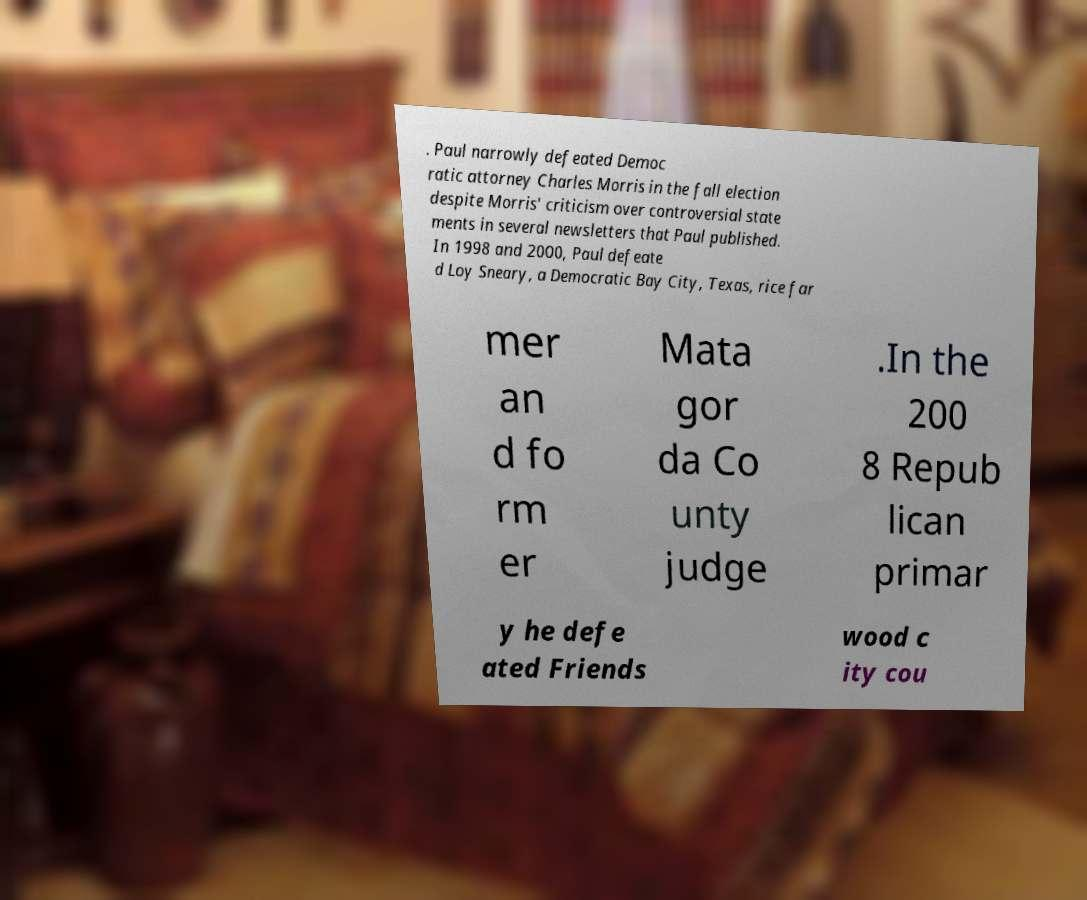Please read and relay the text visible in this image. What does it say? . Paul narrowly defeated Democ ratic attorney Charles Morris in the fall election despite Morris' criticism over controversial state ments in several newsletters that Paul published. In 1998 and 2000, Paul defeate d Loy Sneary, a Democratic Bay City, Texas, rice far mer an d fo rm er Mata gor da Co unty judge .In the 200 8 Repub lican primar y he defe ated Friends wood c ity cou 